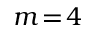<formula> <loc_0><loc_0><loc_500><loc_500>m \, = \, 4</formula> 